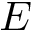Convert formula to latex. <formula><loc_0><loc_0><loc_500><loc_500>E</formula> 